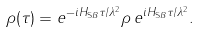Convert formula to latex. <formula><loc_0><loc_0><loc_500><loc_500>\rho ( \tau ) = e ^ { - i H _ { \mathrm S B } \tau / \lambda ^ { 2 } } \rho \, e ^ { i H _ { \mathrm S B } \tau / \lambda ^ { 2 } } .</formula> 